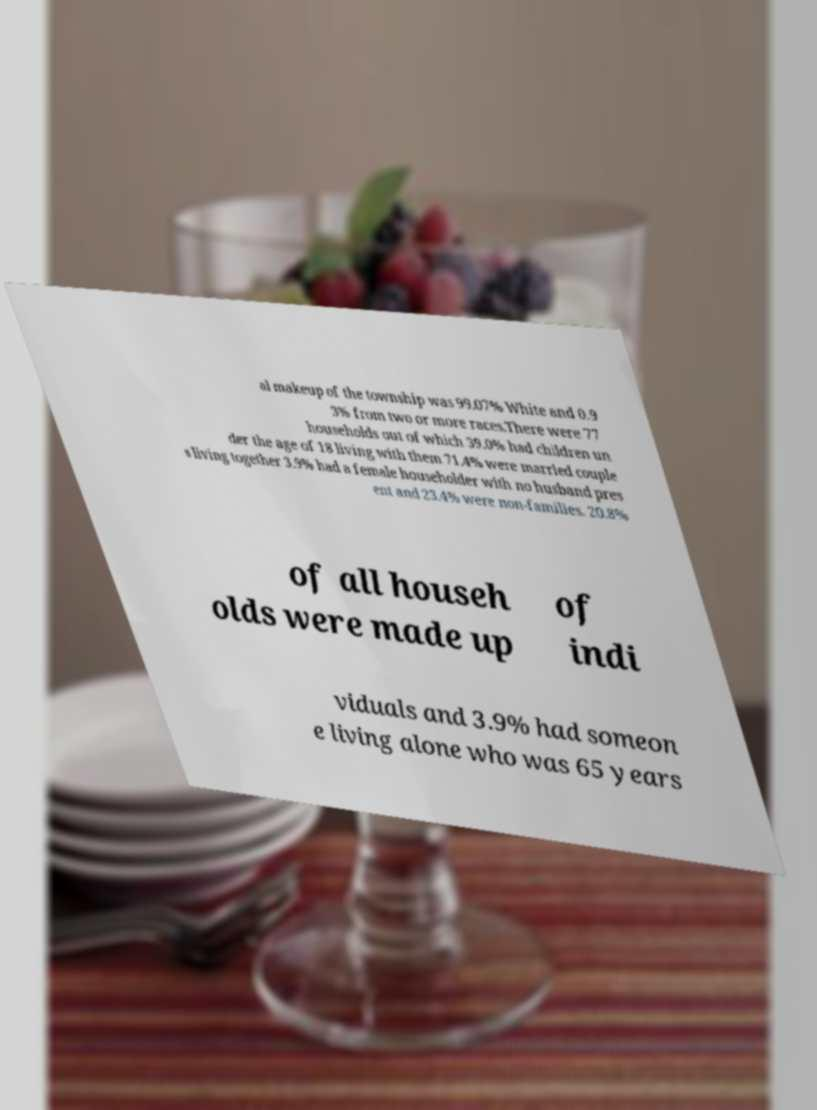For documentation purposes, I need the text within this image transcribed. Could you provide that? al makeup of the township was 99.07% White and 0.9 3% from two or more races.There were 77 households out of which 39.0% had children un der the age of 18 living with them 71.4% were married couple s living together 3.9% had a female householder with no husband pres ent and 23.4% were non-families. 20.8% of all househ olds were made up of indi viduals and 3.9% had someon e living alone who was 65 years 